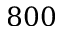<formula> <loc_0><loc_0><loc_500><loc_500>8 0 0</formula> 